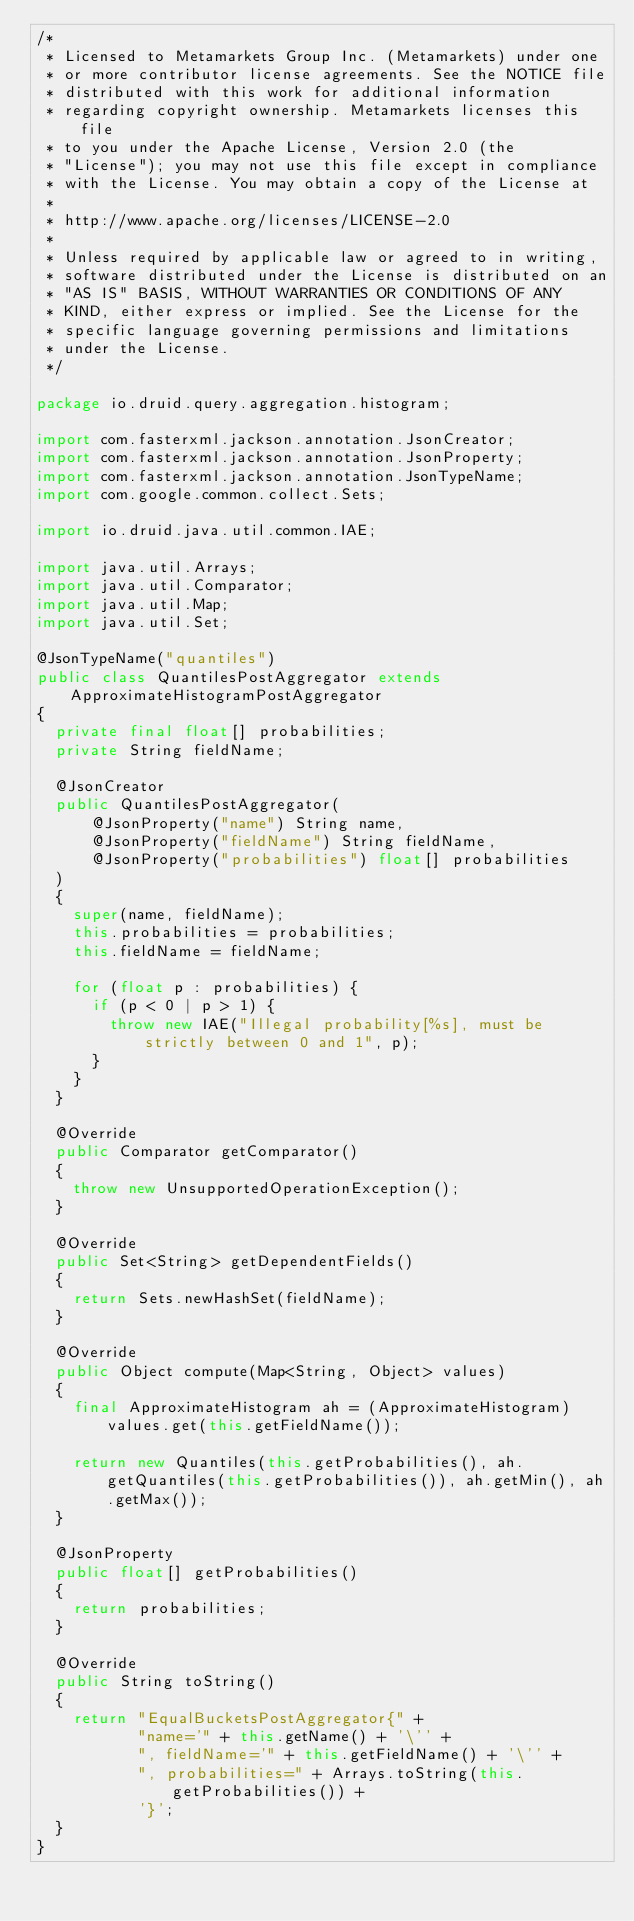Convert code to text. <code><loc_0><loc_0><loc_500><loc_500><_Java_>/*
 * Licensed to Metamarkets Group Inc. (Metamarkets) under one
 * or more contributor license agreements. See the NOTICE file
 * distributed with this work for additional information
 * regarding copyright ownership. Metamarkets licenses this file
 * to you under the Apache License, Version 2.0 (the
 * "License"); you may not use this file except in compliance
 * with the License. You may obtain a copy of the License at
 *
 * http://www.apache.org/licenses/LICENSE-2.0
 *
 * Unless required by applicable law or agreed to in writing,
 * software distributed under the License is distributed on an
 * "AS IS" BASIS, WITHOUT WARRANTIES OR CONDITIONS OF ANY
 * KIND, either express or implied. See the License for the
 * specific language governing permissions and limitations
 * under the License.
 */

package io.druid.query.aggregation.histogram;

import com.fasterxml.jackson.annotation.JsonCreator;
import com.fasterxml.jackson.annotation.JsonProperty;
import com.fasterxml.jackson.annotation.JsonTypeName;
import com.google.common.collect.Sets;

import io.druid.java.util.common.IAE;

import java.util.Arrays;
import java.util.Comparator;
import java.util.Map;
import java.util.Set;

@JsonTypeName("quantiles")
public class QuantilesPostAggregator extends ApproximateHistogramPostAggregator
{
  private final float[] probabilities;
  private String fieldName;

  @JsonCreator
  public QuantilesPostAggregator(
      @JsonProperty("name") String name,
      @JsonProperty("fieldName") String fieldName,
      @JsonProperty("probabilities") float[] probabilities
  )
  {
    super(name, fieldName);
    this.probabilities = probabilities;
    this.fieldName = fieldName;

    for (float p : probabilities) {
      if (p < 0 | p > 1) {
        throw new IAE("Illegal probability[%s], must be strictly between 0 and 1", p);
      }
    }
  }

  @Override
  public Comparator getComparator()
  {
    throw new UnsupportedOperationException();
  }

  @Override
  public Set<String> getDependentFields()
  {
    return Sets.newHashSet(fieldName);
  }

  @Override
  public Object compute(Map<String, Object> values)
  {
    final ApproximateHistogram ah = (ApproximateHistogram) values.get(this.getFieldName());

    return new Quantiles(this.getProbabilities(), ah.getQuantiles(this.getProbabilities()), ah.getMin(), ah.getMax());
  }

  @JsonProperty
  public float[] getProbabilities()
  {
    return probabilities;
  }

  @Override
  public String toString()
  {
    return "EqualBucketsPostAggregator{" +
           "name='" + this.getName() + '\'' +
           ", fieldName='" + this.getFieldName() + '\'' +
           ", probabilities=" + Arrays.toString(this.getProbabilities()) +
           '}';
  }
}
</code> 